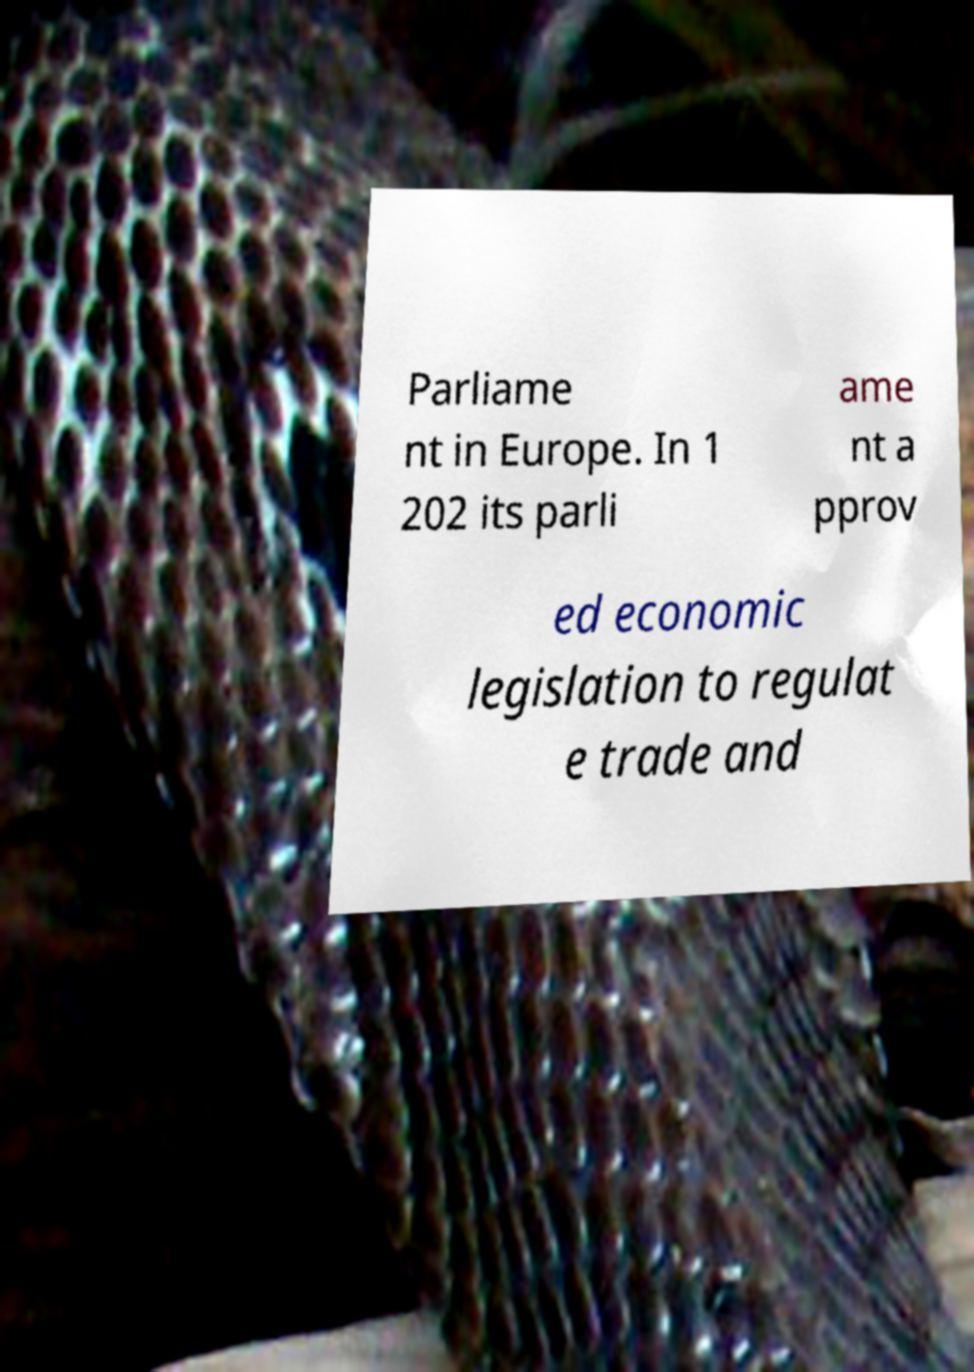Could you assist in decoding the text presented in this image and type it out clearly? Parliame nt in Europe. In 1 202 its parli ame nt a pprov ed economic legislation to regulat e trade and 